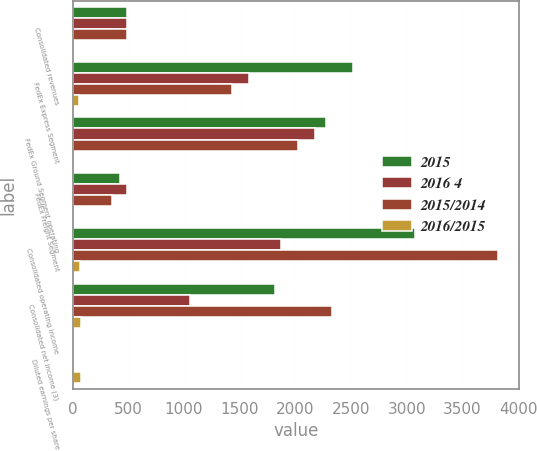Convert chart. <chart><loc_0><loc_0><loc_500><loc_500><stacked_bar_chart><ecel><fcel>Consolidated revenues<fcel>FedEx Express Segment<fcel>FedEx Ground Segment operating<fcel>FedEx Freight Segment<fcel>Consolidated operating income<fcel>Consolidated net income (3)<fcel>Diluted earnings per share<nl><fcel>2015<fcel>484<fcel>2519<fcel>2276<fcel>426<fcel>3077<fcel>1820<fcel>6.51<nl><fcel>2016 4<fcel>484<fcel>1584<fcel>2172<fcel>484<fcel>1867<fcel>1050<fcel>3.65<nl><fcel>2015/2014<fcel>484<fcel>1428<fcel>2021<fcel>351<fcel>3815<fcel>2324<fcel>7.48<nl><fcel>2016/2015<fcel>6<fcel>59<fcel>5<fcel>12<fcel>65<fcel>73<fcel>78<nl></chart> 